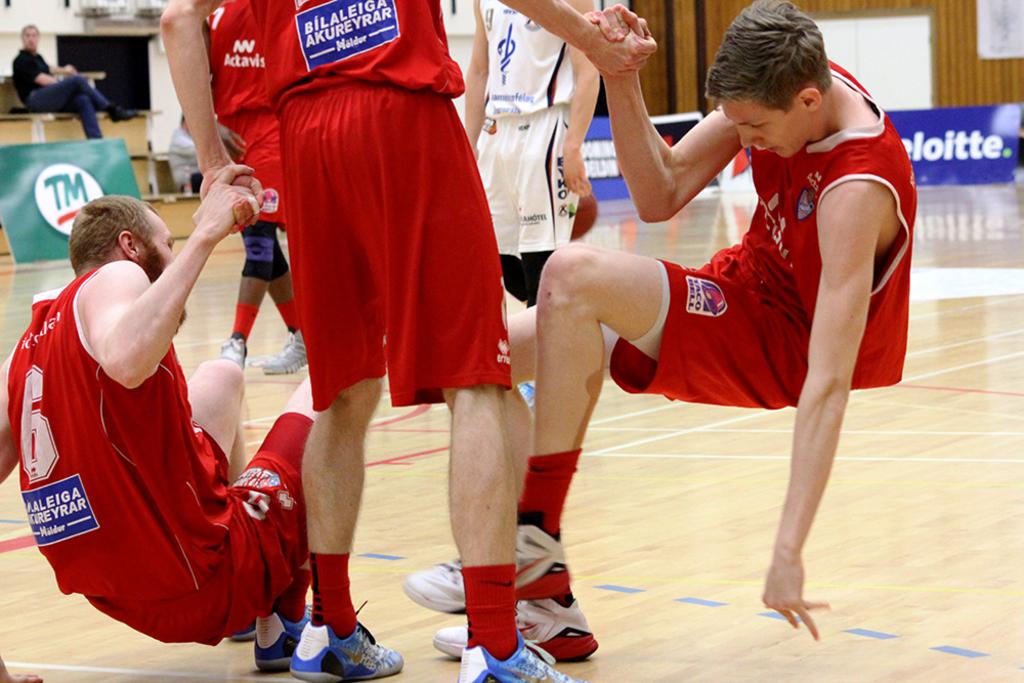What is the player number on the left that is getting up?
Offer a very short reply. 6. What is the name on the shorts of the player on the right?
Make the answer very short. Taco bell. 